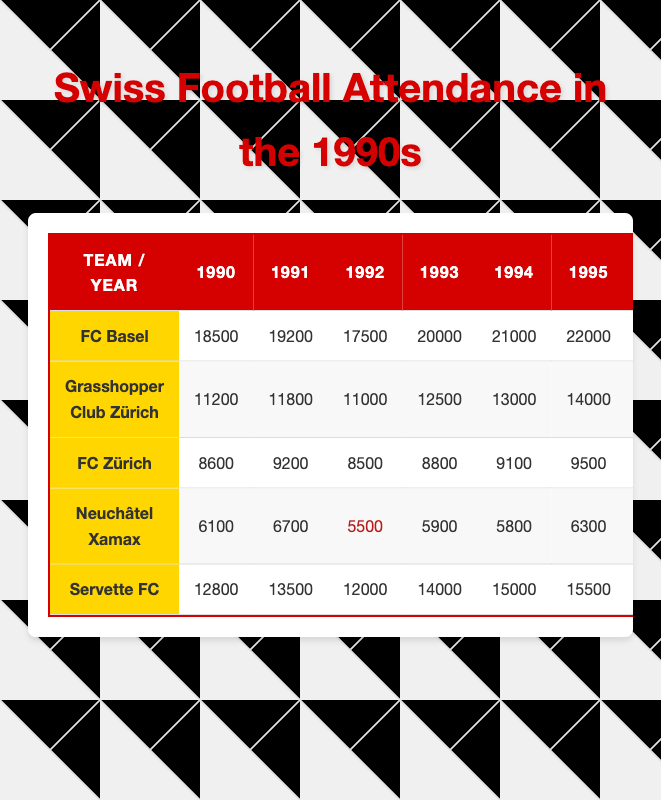What was the highest attendance for FC Basel in the 1990s? The highest attendance for FC Basel is found in the year 1999, where it reached 26000.
Answer: 26000 Which team had the lowest attendance in 1992? Referring to the table, Neuchâtel Xamax had the lowest attendance in 1992, recorded at 5500.
Answer: 5500 What is the average attendance of Grasshopper Club Zürich from 1990 to 1999? To calculate the average, sum the attendances for Grasshopper Club Zürich for each year (11200 + 11800 + 11000 + 12500 + 13000 + 14000 + 14500 + 15000 + 15500 + 16000 = 139500), then divide by 10, resulting in an average of 13950.
Answer: 13950 Did Servette FC have a higher attendance than FC Zürich in every season? By comparing their attendances year by year, Servette FC consistently outperformed FC Zürich each season listed in the table. Therefore, the answer is yes.
Answer: Yes What is the total attendance for Neuchâtel Xamax over the entire decade? By adding up Neuchâtel Xamax's attendances (6100 + 6700 + 5500 + 5900 + 5800 + 6300 + 6000 + 6200 + 6400 + 6500 = 60500), we find the total attendance for the decade is 60500.
Answer: 60500 Which team showed the highest increase in attendance from 1990 to 1999? By calculating the differences, FC Basel went from 18500 in 1990 to 26000 in 1999, indicating an increase of 7500, which is the highest compared to other teams.
Answer: FC Basel How many times did FC Zürich have an attendance below 9000? By reviewing the year-by-year attendance, FC Zürich had attendances below 9000 in 1990 (8600) and 1992 (8500), which totals 2 occurrences.
Answer: 2 What was the combined attendance for all teams in 1995? The combined attendance for 1995 can be calculated by summing (22000 + 14000 + 9500 + 6300 + 15500 = 63400). Therefore, the combined attendance for all teams is 63400.
Answer: 63400 Which team had the greatest percentage increase in attendance from 1996 to 1997? FC Basel's attendance jumped from 23000 in 1996 to 24000 in 1997, a gain of 4.35%. Other teams' increases are lower; thus, FC Basel holds the greatest percentage increase.
Answer: FC Basel Is it true that every team had an increasing trend in attendance from 1990 to 1999? By analyzing the attendances, it's clear that Neuchâtel Xamax's attendance in 1992 decreased from 6100 to 5500, showing a decline. Therefore, it's false that all teams had an increasing trend.
Answer: No 